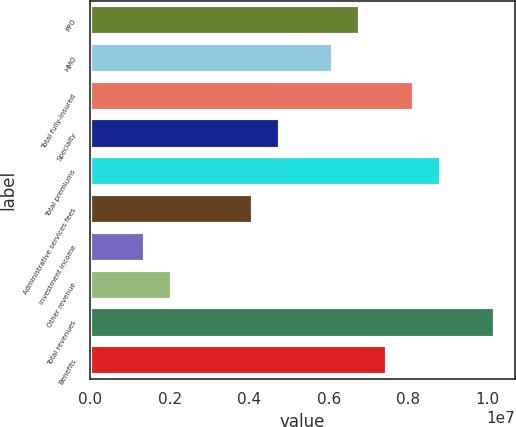<chart> <loc_0><loc_0><loc_500><loc_500><bar_chart><fcel>PPO<fcel>HMO<fcel>Total fully-insured<fcel>Specialty<fcel>Total premiums<fcel>Administrative services fees<fcel>Investment income<fcel>Other revenue<fcel>Total revenues<fcel>Benefits<nl><fcel>6.79478e+06<fcel>6.11844e+06<fcel>8.14747e+06<fcel>4.76575e+06<fcel>8.82381e+06<fcel>4.08941e+06<fcel>1.38404e+06<fcel>2.06038e+06<fcel>1.01765e+07<fcel>7.47113e+06<nl></chart> 